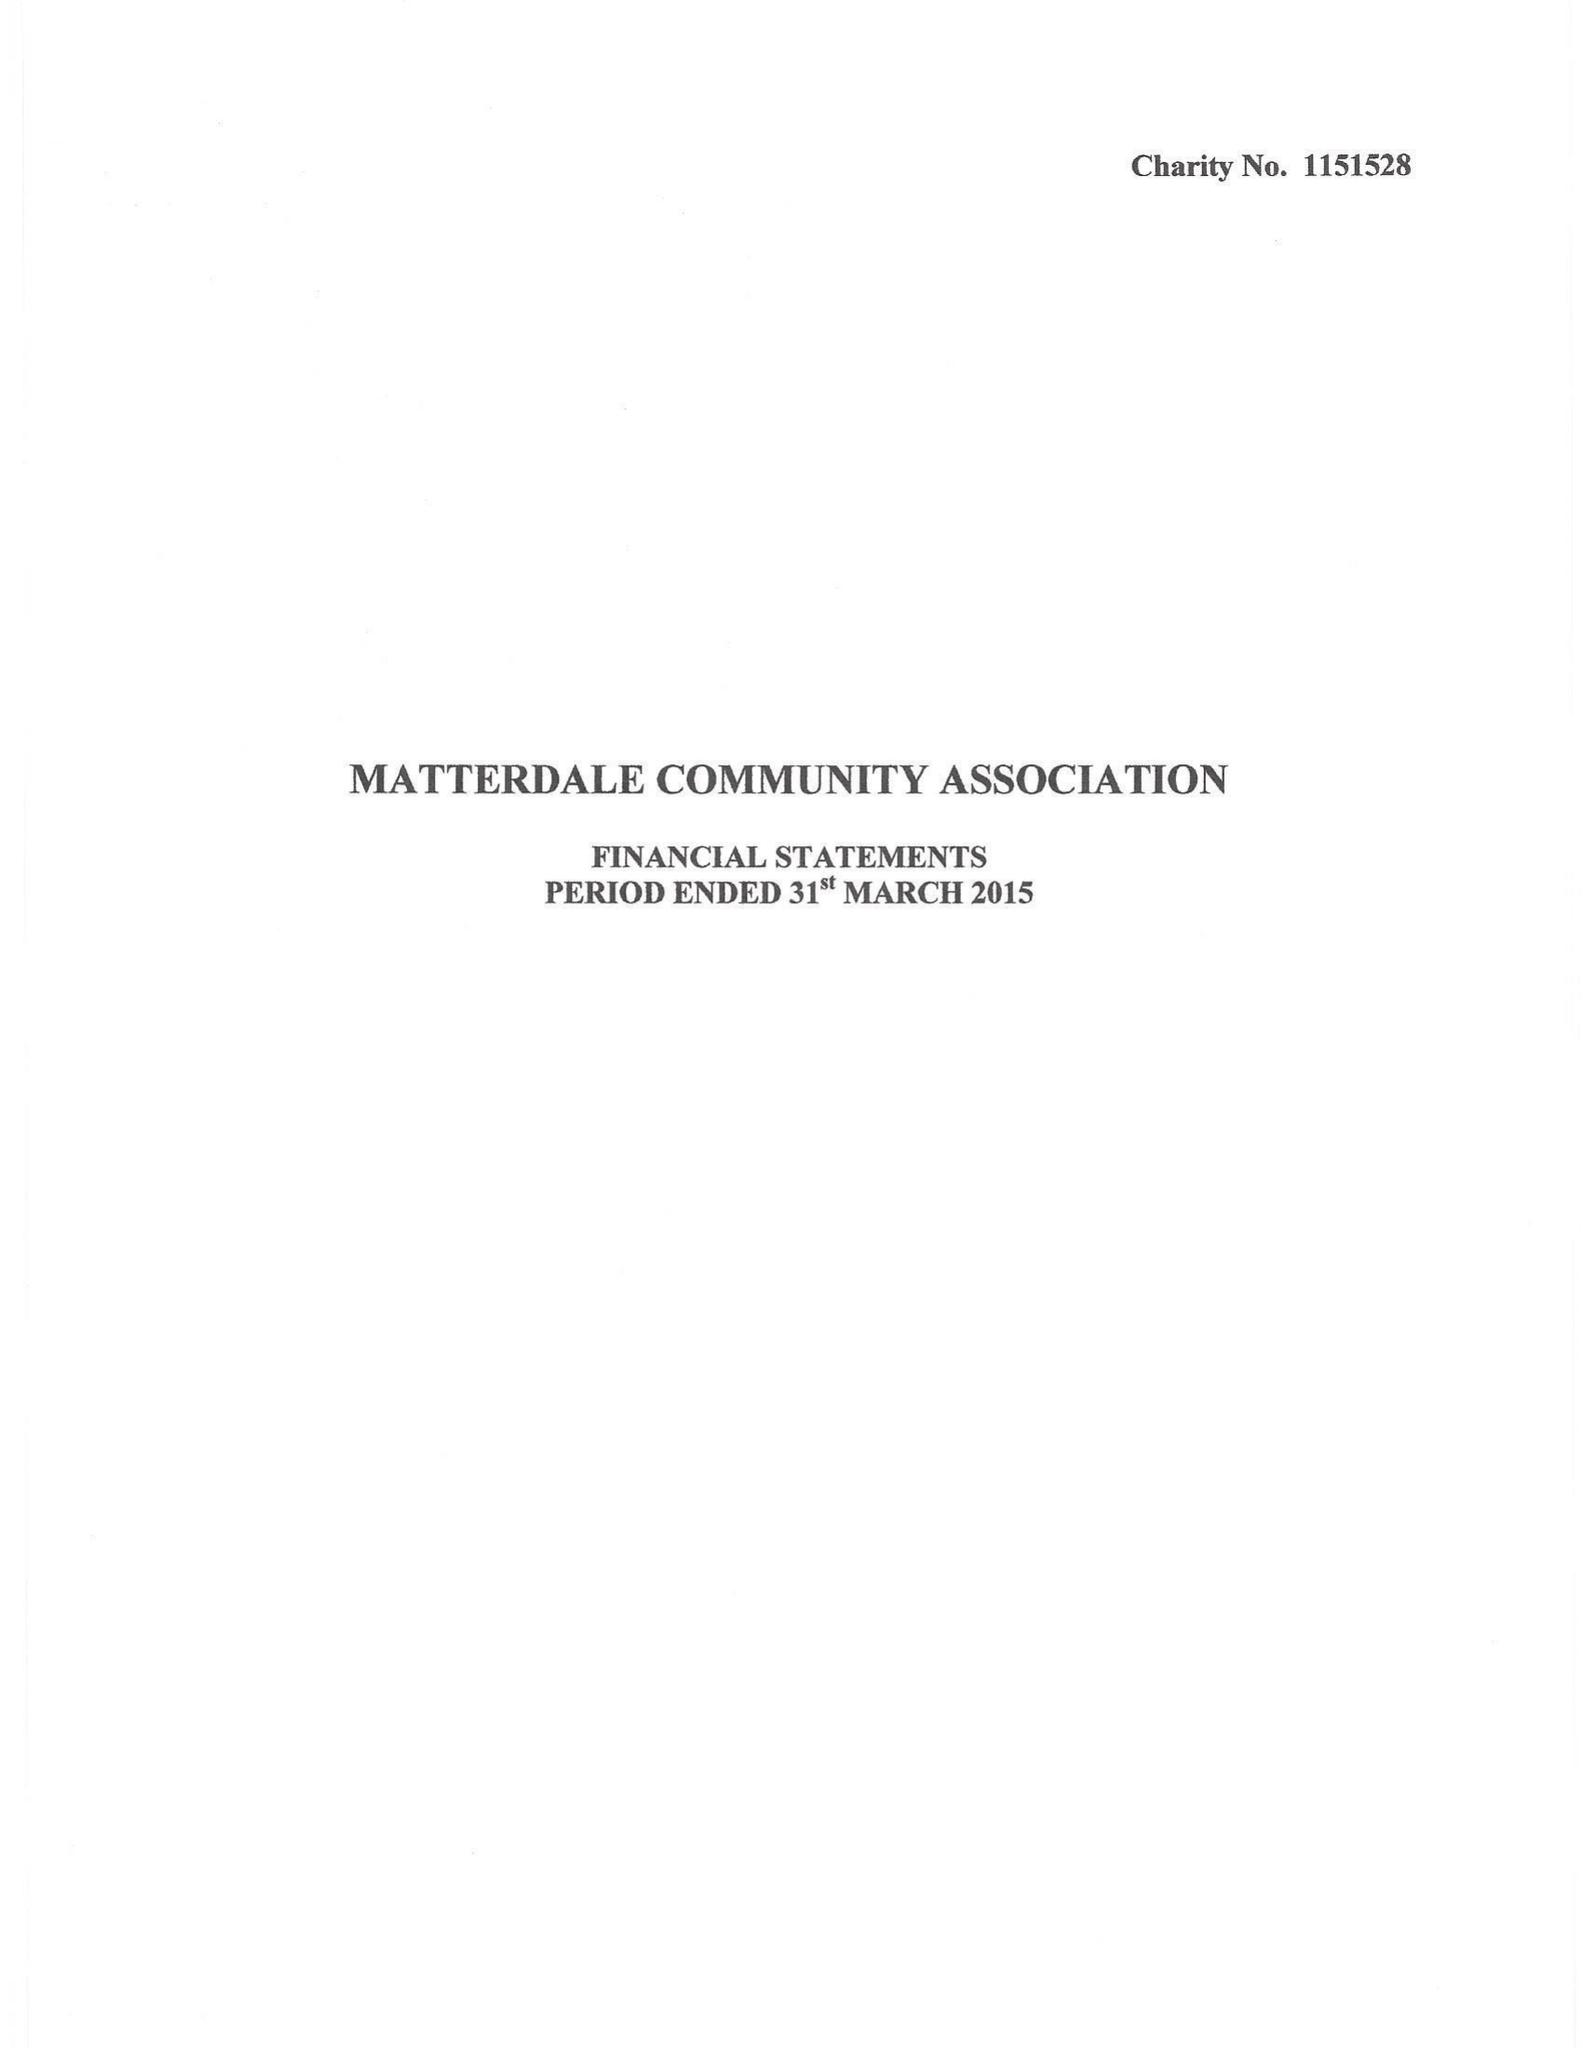What is the value for the address__street_line?
Answer the question using a single word or phrase. THE OLD VICARAGE 